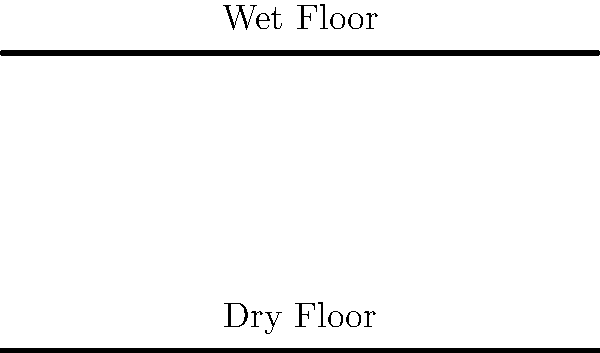In the diagram above, force vectors are shown for a person walking on dry and wet floors in a food service area. Based on the relative lengths of the force ($\vec{F}$) and friction ($\vec{f}$) vectors, which floor condition presents a higher risk of slip and fall, and why? To understand the slip and fall risk, we need to analyze the force vectors:

1. On both surfaces, $\vec{F}$ represents the applied force from the person walking, and $\vec{f}$ represents the friction force opposing motion.

2. For slip prevention, the friction force must be greater than or equal to the horizontal component of the applied force.

3. On the dry floor:
   - The friction vector $\vec{f}$ is relatively long compared to $\vec{F}$.
   - This indicates a high coefficient of friction, providing good traction.

4. On the wet floor:
   - The friction vector $\vec{f}$ is much shorter compared to $\vec{F}$.
   - This indicates a low coefficient of friction, providing poor traction.

5. The ratio of friction to applied force is crucial:
   - Dry floor: $\frac{|\vec{f}|}{|\vec{F}|}$ is larger
   - Wet floor: $\frac{|\vec{f}|}{|\vec{F}|}$ is smaller

6. A smaller ratio on the wet floor means there's less friction to counteract the applied force, increasing the likelihood of slipping.

Therefore, the wet floor presents a higher risk of slip and fall due to the reduced friction force relative to the applied force.
Answer: Wet floor; lower friction-to-force ratio. 